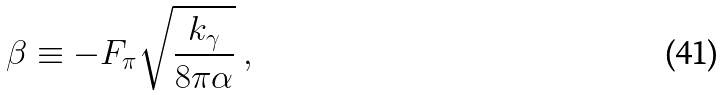Convert formula to latex. <formula><loc_0><loc_0><loc_500><loc_500>\beta \equiv - F _ { \pi } \sqrt { \frac { k _ { \gamma } } { 8 \pi \alpha } } \ ,</formula> 